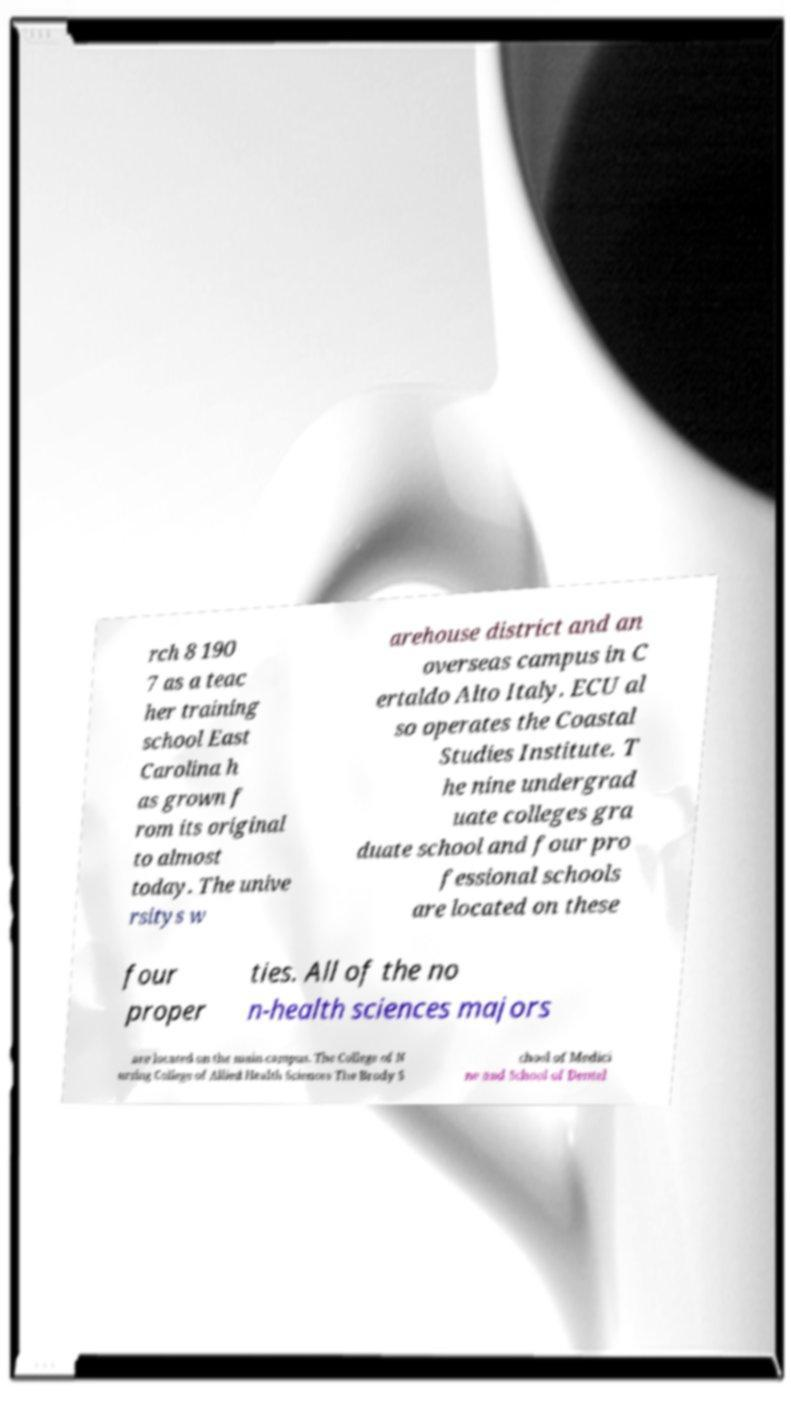Can you accurately transcribe the text from the provided image for me? rch 8 190 7 as a teac her training school East Carolina h as grown f rom its original to almost today. The unive rsitys w arehouse district and an overseas campus in C ertaldo Alto Italy. ECU al so operates the Coastal Studies Institute. T he nine undergrad uate colleges gra duate school and four pro fessional schools are located on these four proper ties. All of the no n-health sciences majors are located on the main campus. The College of N ursing College of Allied Health Sciences The Brody S chool of Medici ne and School of Dental 